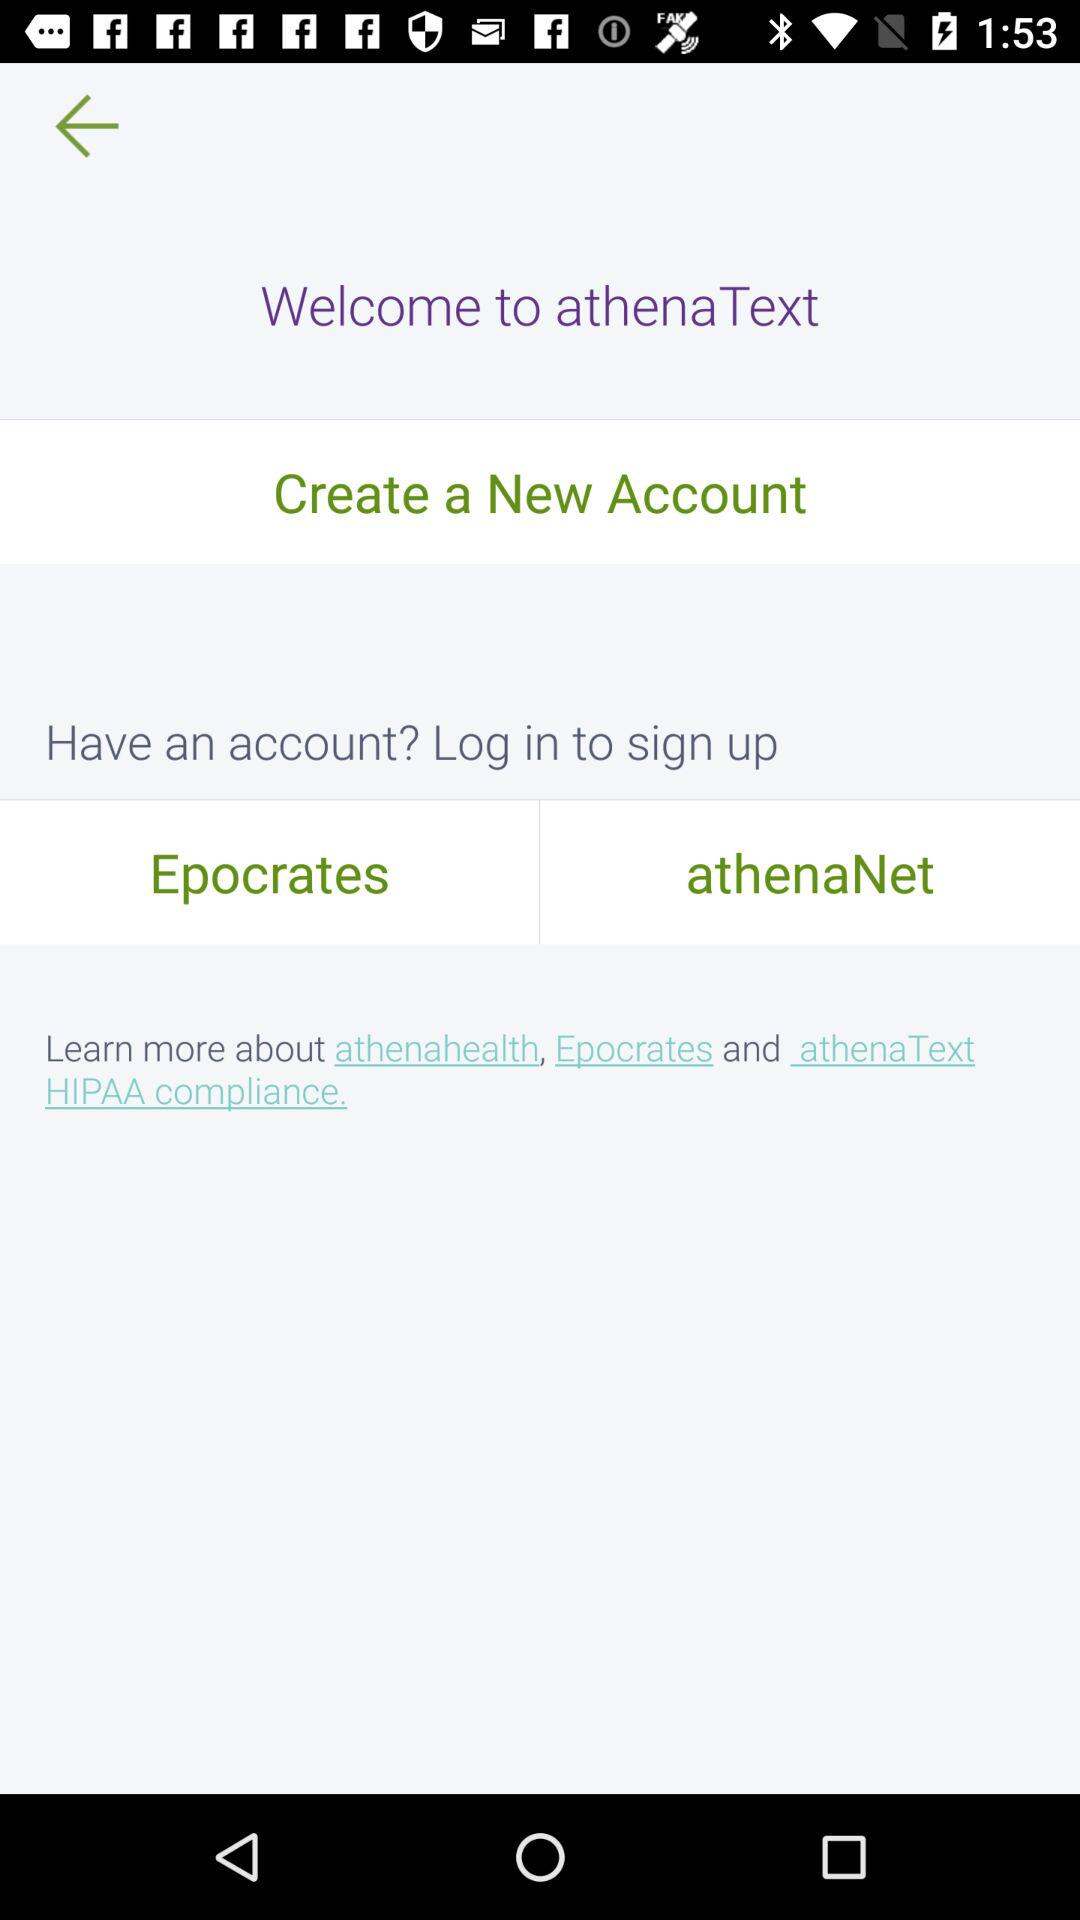What is the name of the application? The application name is "athenaText". 